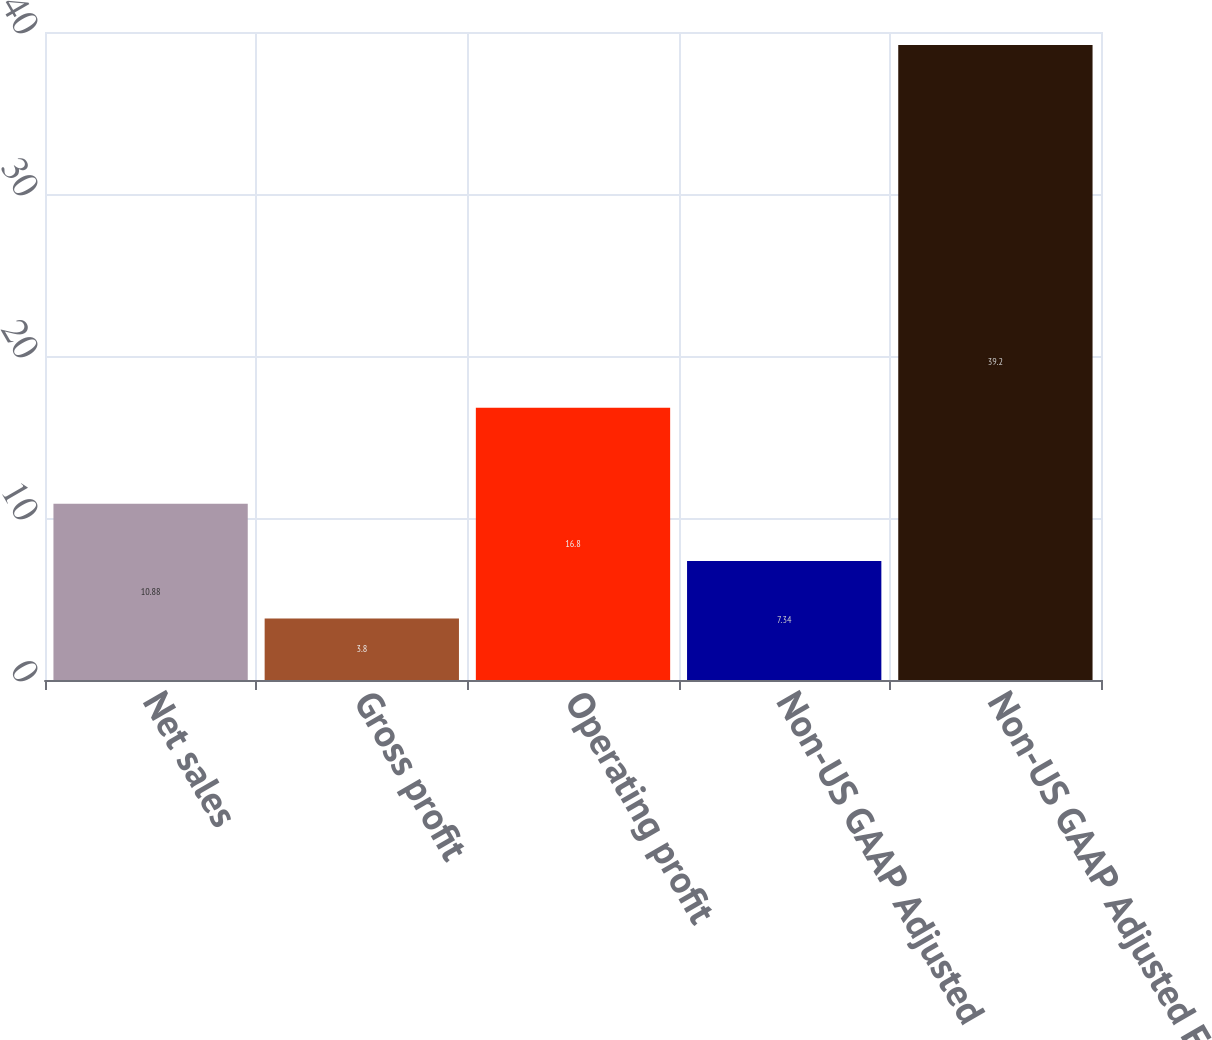Convert chart. <chart><loc_0><loc_0><loc_500><loc_500><bar_chart><fcel>Net sales<fcel>Gross profit<fcel>Operating profit<fcel>Non-US GAAP Adjusted<fcel>Non-US GAAP Adjusted EPS ^(2)<nl><fcel>10.88<fcel>3.8<fcel>16.8<fcel>7.34<fcel>39.2<nl></chart> 